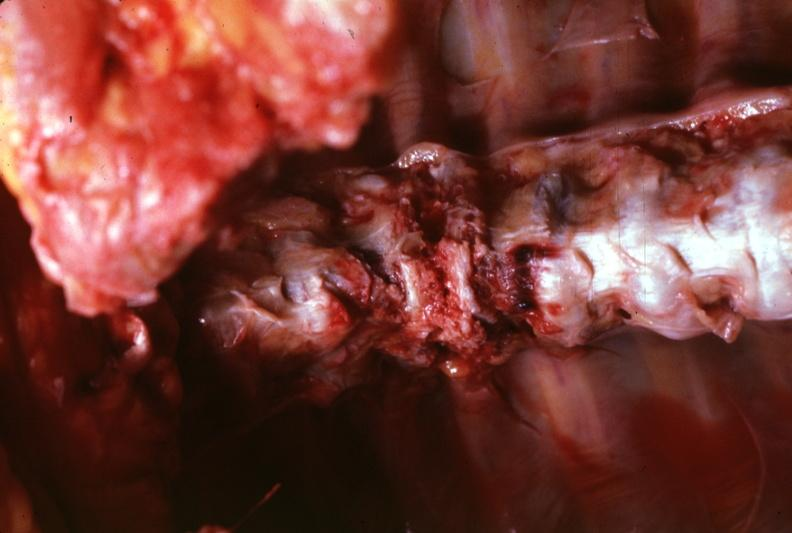what does this image show?
Answer the question using a single word or phrase. View of spinal column in situ shown rather close-up quite good 